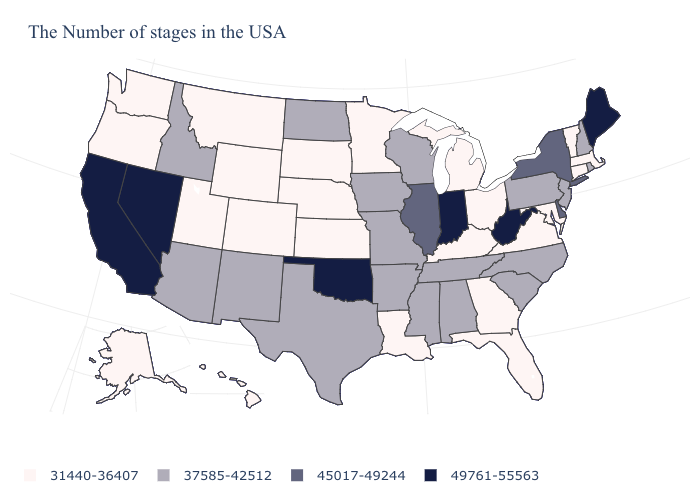Does Virginia have the lowest value in the USA?
Write a very short answer. Yes. Name the states that have a value in the range 31440-36407?
Write a very short answer. Massachusetts, Vermont, Connecticut, Maryland, Virginia, Ohio, Florida, Georgia, Michigan, Kentucky, Louisiana, Minnesota, Kansas, Nebraska, South Dakota, Wyoming, Colorado, Utah, Montana, Washington, Oregon, Alaska, Hawaii. What is the highest value in the USA?
Concise answer only. 49761-55563. Among the states that border Oregon , which have the lowest value?
Short answer required. Washington. What is the value of New Jersey?
Be succinct. 37585-42512. Does the map have missing data?
Write a very short answer. No. Among the states that border Indiana , which have the highest value?
Keep it brief. Illinois. Does the first symbol in the legend represent the smallest category?
Give a very brief answer. Yes. What is the highest value in the USA?
Short answer required. 49761-55563. Name the states that have a value in the range 37585-42512?
Short answer required. Rhode Island, New Hampshire, New Jersey, Pennsylvania, North Carolina, South Carolina, Alabama, Tennessee, Wisconsin, Mississippi, Missouri, Arkansas, Iowa, Texas, North Dakota, New Mexico, Arizona, Idaho. What is the highest value in the USA?
Give a very brief answer. 49761-55563. What is the value of Illinois?
Give a very brief answer. 45017-49244. What is the highest value in the USA?
Concise answer only. 49761-55563. Is the legend a continuous bar?
Short answer required. No. Does the first symbol in the legend represent the smallest category?
Answer briefly. Yes. 